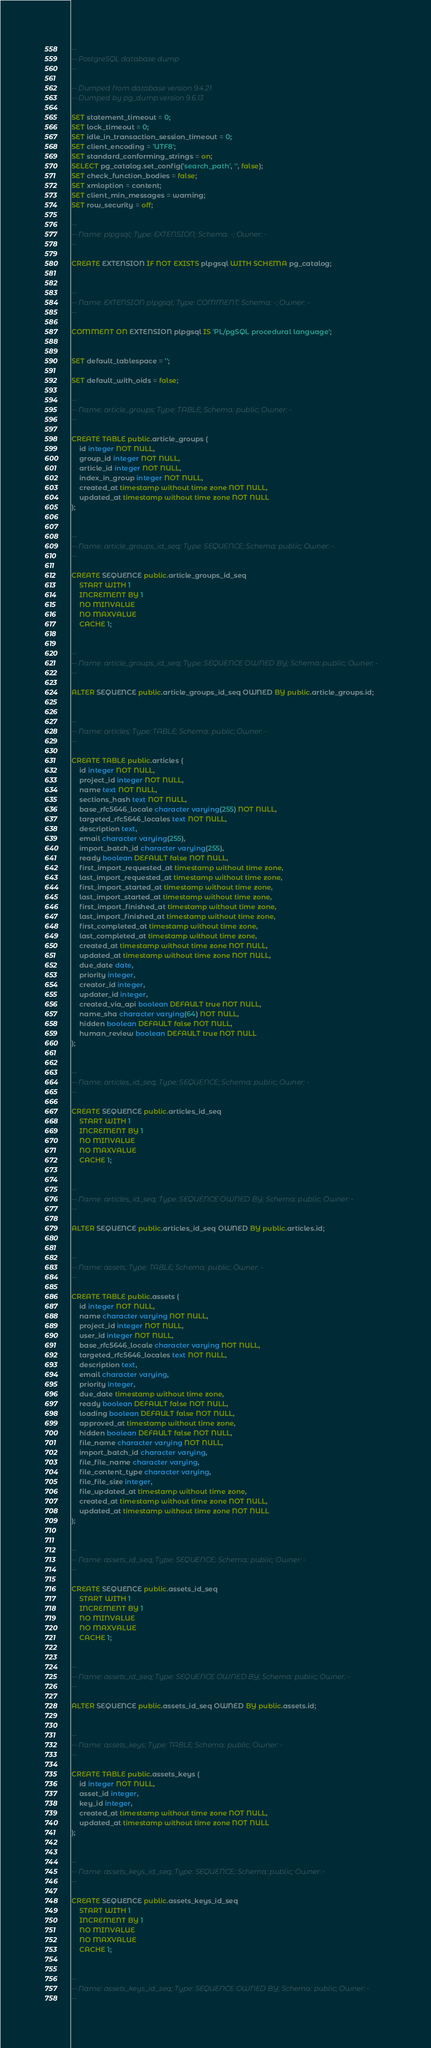<code> <loc_0><loc_0><loc_500><loc_500><_SQL_>--
-- PostgreSQL database dump
--

-- Dumped from database version 9.4.21
-- Dumped by pg_dump version 9.6.13

SET statement_timeout = 0;
SET lock_timeout = 0;
SET idle_in_transaction_session_timeout = 0;
SET client_encoding = 'UTF8';
SET standard_conforming_strings = on;
SELECT pg_catalog.set_config('search_path', '', false);
SET check_function_bodies = false;
SET xmloption = content;
SET client_min_messages = warning;
SET row_security = off;

--
-- Name: plpgsql; Type: EXTENSION; Schema: -; Owner: -
--

CREATE EXTENSION IF NOT EXISTS plpgsql WITH SCHEMA pg_catalog;


--
-- Name: EXTENSION plpgsql; Type: COMMENT; Schema: -; Owner: -
--

COMMENT ON EXTENSION plpgsql IS 'PL/pgSQL procedural language';


SET default_tablespace = '';

SET default_with_oids = false;

--
-- Name: article_groups; Type: TABLE; Schema: public; Owner: -
--

CREATE TABLE public.article_groups (
    id integer NOT NULL,
    group_id integer NOT NULL,
    article_id integer NOT NULL,
    index_in_group integer NOT NULL,
    created_at timestamp without time zone NOT NULL,
    updated_at timestamp without time zone NOT NULL
);


--
-- Name: article_groups_id_seq; Type: SEQUENCE; Schema: public; Owner: -
--

CREATE SEQUENCE public.article_groups_id_seq
    START WITH 1
    INCREMENT BY 1
    NO MINVALUE
    NO MAXVALUE
    CACHE 1;


--
-- Name: article_groups_id_seq; Type: SEQUENCE OWNED BY; Schema: public; Owner: -
--

ALTER SEQUENCE public.article_groups_id_seq OWNED BY public.article_groups.id;


--
-- Name: articles; Type: TABLE; Schema: public; Owner: -
--

CREATE TABLE public.articles (
    id integer NOT NULL,
    project_id integer NOT NULL,
    name text NOT NULL,
    sections_hash text NOT NULL,
    base_rfc5646_locale character varying(255) NOT NULL,
    targeted_rfc5646_locales text NOT NULL,
    description text,
    email character varying(255),
    import_batch_id character varying(255),
    ready boolean DEFAULT false NOT NULL,
    first_import_requested_at timestamp without time zone,
    last_import_requested_at timestamp without time zone,
    first_import_started_at timestamp without time zone,
    last_import_started_at timestamp without time zone,
    first_import_finished_at timestamp without time zone,
    last_import_finished_at timestamp without time zone,
    first_completed_at timestamp without time zone,
    last_completed_at timestamp without time zone,
    created_at timestamp without time zone NOT NULL,
    updated_at timestamp without time zone NOT NULL,
    due_date date,
    priority integer,
    creator_id integer,
    updater_id integer,
    created_via_api boolean DEFAULT true NOT NULL,
    name_sha character varying(64) NOT NULL,
    hidden boolean DEFAULT false NOT NULL,
    human_review boolean DEFAULT true NOT NULL
);


--
-- Name: articles_id_seq; Type: SEQUENCE; Schema: public; Owner: -
--

CREATE SEQUENCE public.articles_id_seq
    START WITH 1
    INCREMENT BY 1
    NO MINVALUE
    NO MAXVALUE
    CACHE 1;


--
-- Name: articles_id_seq; Type: SEQUENCE OWNED BY; Schema: public; Owner: -
--

ALTER SEQUENCE public.articles_id_seq OWNED BY public.articles.id;


--
-- Name: assets; Type: TABLE; Schema: public; Owner: -
--

CREATE TABLE public.assets (
    id integer NOT NULL,
    name character varying NOT NULL,
    project_id integer NOT NULL,
    user_id integer NOT NULL,
    base_rfc5646_locale character varying NOT NULL,
    targeted_rfc5646_locales text NOT NULL,
    description text,
    email character varying,
    priority integer,
    due_date timestamp without time zone,
    ready boolean DEFAULT false NOT NULL,
    loading boolean DEFAULT false NOT NULL,
    approved_at timestamp without time zone,
    hidden boolean DEFAULT false NOT NULL,
    file_name character varying NOT NULL,
    import_batch_id character varying,
    file_file_name character varying,
    file_content_type character varying,
    file_file_size integer,
    file_updated_at timestamp without time zone,
    created_at timestamp without time zone NOT NULL,
    updated_at timestamp without time zone NOT NULL
);


--
-- Name: assets_id_seq; Type: SEQUENCE; Schema: public; Owner: -
--

CREATE SEQUENCE public.assets_id_seq
    START WITH 1
    INCREMENT BY 1
    NO MINVALUE
    NO MAXVALUE
    CACHE 1;


--
-- Name: assets_id_seq; Type: SEQUENCE OWNED BY; Schema: public; Owner: -
--

ALTER SEQUENCE public.assets_id_seq OWNED BY public.assets.id;


--
-- Name: assets_keys; Type: TABLE; Schema: public; Owner: -
--

CREATE TABLE public.assets_keys (
    id integer NOT NULL,
    asset_id integer,
    key_id integer,
    created_at timestamp without time zone NOT NULL,
    updated_at timestamp without time zone NOT NULL
);


--
-- Name: assets_keys_id_seq; Type: SEQUENCE; Schema: public; Owner: -
--

CREATE SEQUENCE public.assets_keys_id_seq
    START WITH 1
    INCREMENT BY 1
    NO MINVALUE
    NO MAXVALUE
    CACHE 1;


--
-- Name: assets_keys_id_seq; Type: SEQUENCE OWNED BY; Schema: public; Owner: -
--
</code> 